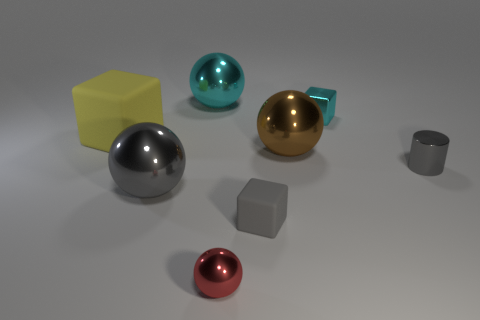Add 2 brown cylinders. How many objects exist? 10 Subtract all cylinders. How many objects are left? 7 Add 7 cyan cubes. How many cyan cubes are left? 8 Add 4 big yellow rubber cubes. How many big yellow rubber cubes exist? 5 Subtract 0 blue balls. How many objects are left? 8 Subtract all big brown matte cubes. Subtract all small red balls. How many objects are left? 7 